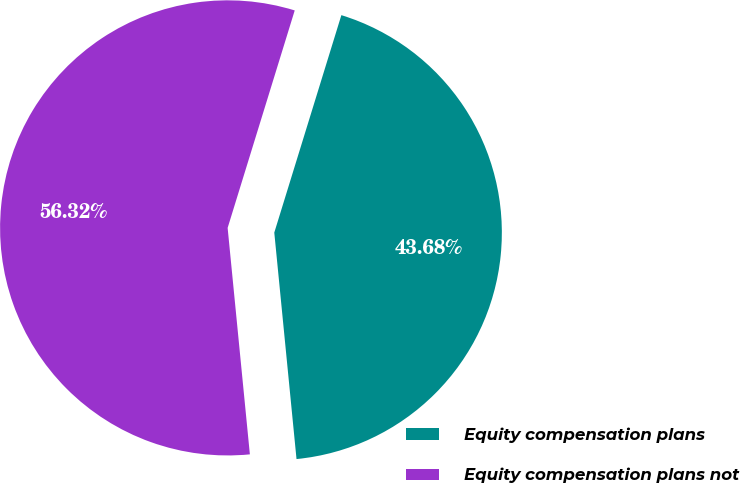<chart> <loc_0><loc_0><loc_500><loc_500><pie_chart><fcel>Equity compensation plans<fcel>Equity compensation plans not<nl><fcel>43.68%<fcel>56.32%<nl></chart> 